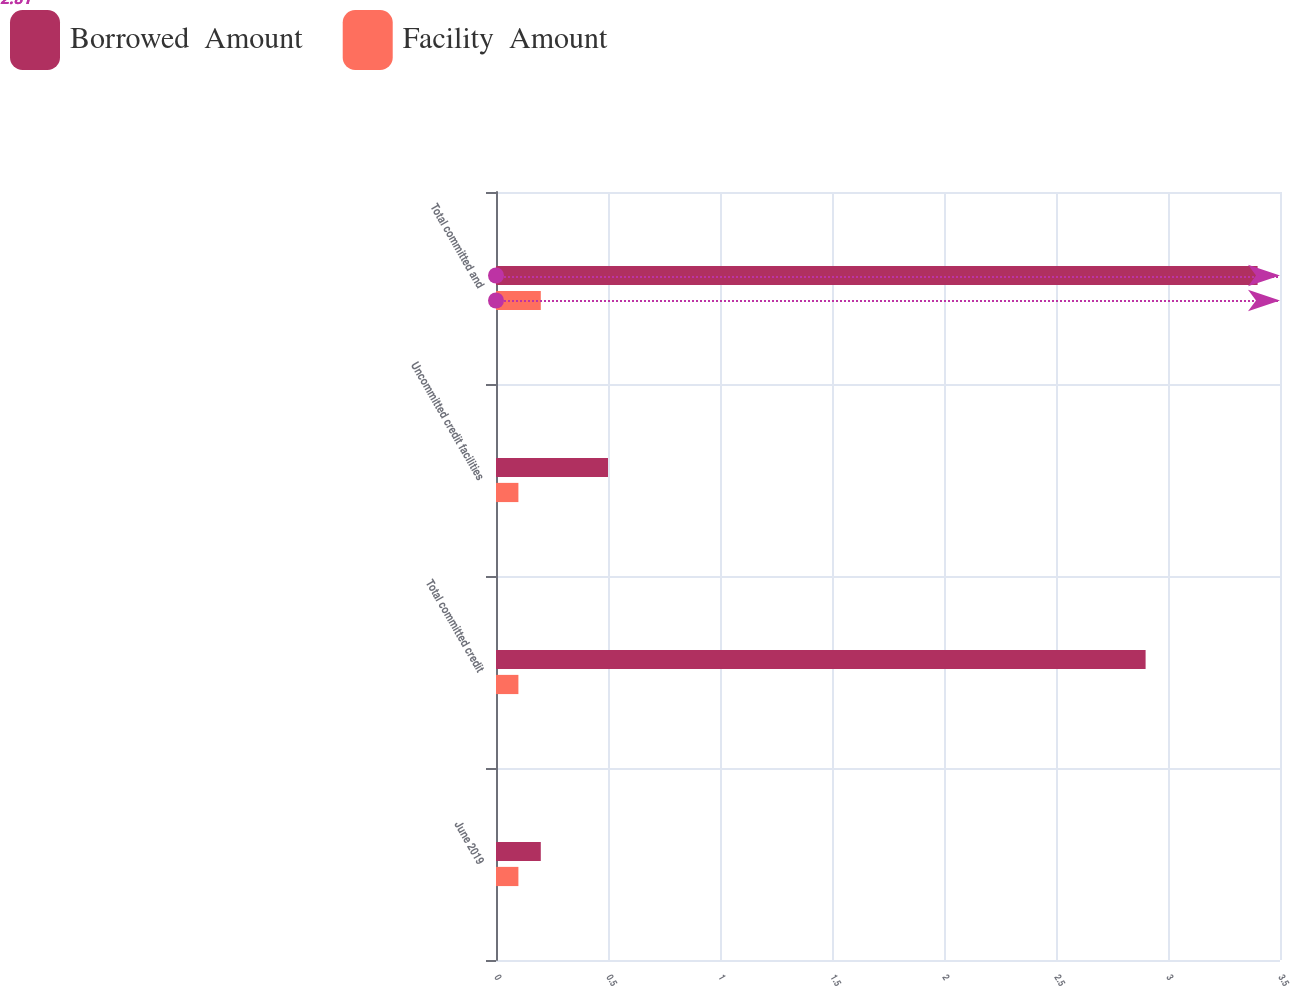Convert chart. <chart><loc_0><loc_0><loc_500><loc_500><stacked_bar_chart><ecel><fcel>June 2019<fcel>Total committed credit<fcel>Uncommitted credit facilities<fcel>Total committed and<nl><fcel>Borrowed  Amount<fcel>0.2<fcel>2.9<fcel>0.5<fcel>3.4<nl><fcel>Facility  Amount<fcel>0.1<fcel>0.1<fcel>0.1<fcel>0.2<nl></chart> 